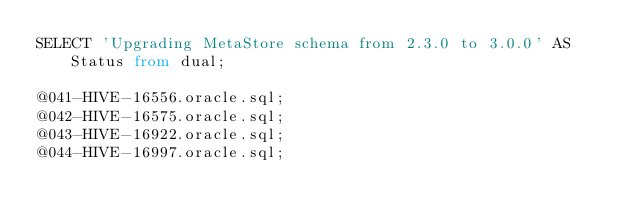<code> <loc_0><loc_0><loc_500><loc_500><_SQL_>SELECT 'Upgrading MetaStore schema from 2.3.0 to 3.0.0' AS Status from dual;

@041-HIVE-16556.oracle.sql;
@042-HIVE-16575.oracle.sql;
@043-HIVE-16922.oracle.sql;
@044-HIVE-16997.oracle.sql;</code> 